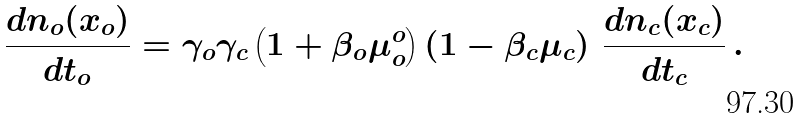Convert formula to latex. <formula><loc_0><loc_0><loc_500><loc_500>\frac { d n _ { o } ( x _ { o } ) } { d t _ { o } } = \gamma _ { o } \gamma _ { c } \left ( 1 + \beta _ { o } \mu _ { o } ^ { o } \right ) \left ( 1 - \beta _ { c } \mu _ { c } \right ) \, \frac { d n _ { c } ( x _ { c } ) } { d t _ { c } } \, .</formula> 